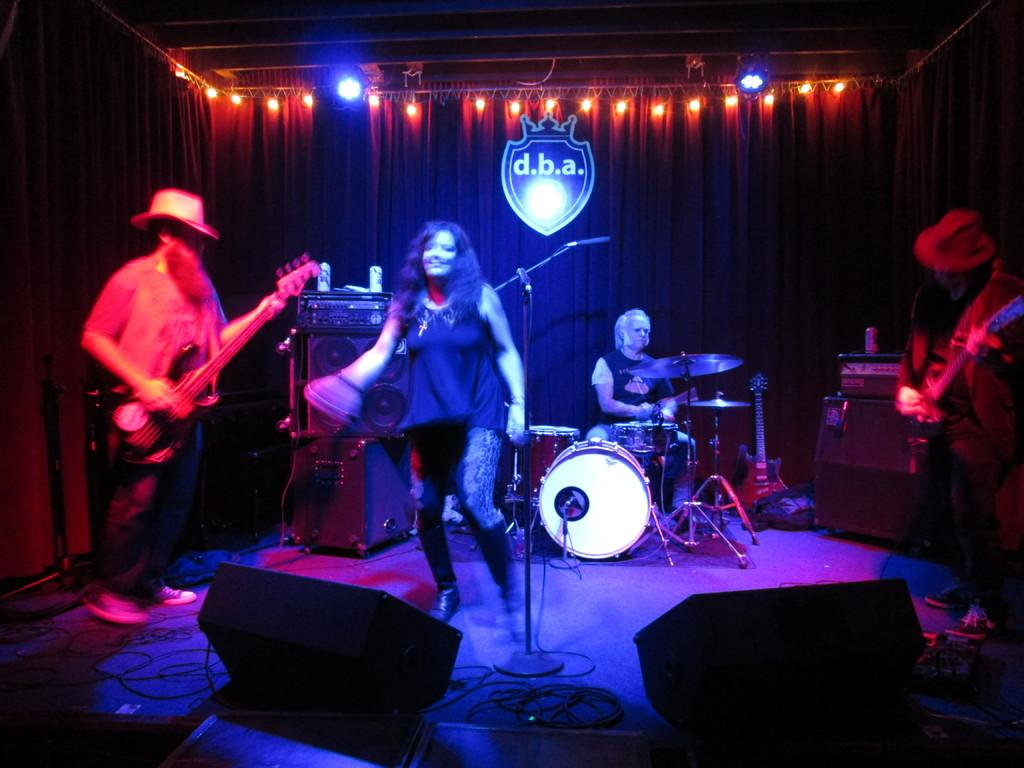What are the people in the image doing? The people in the image are playing musical instruments and singing songs. What objects are they using while performing? They are in front of a microphone. Where are they performing? They are on a stage. What type of match is being played in the image? There is no match being played in the image; it features a group of people playing musical instruments and singing songs. What is the source of power for the instruments in the image? The facts provided do not mention the source of power for the instruments, so it cannot be determined from the image. 